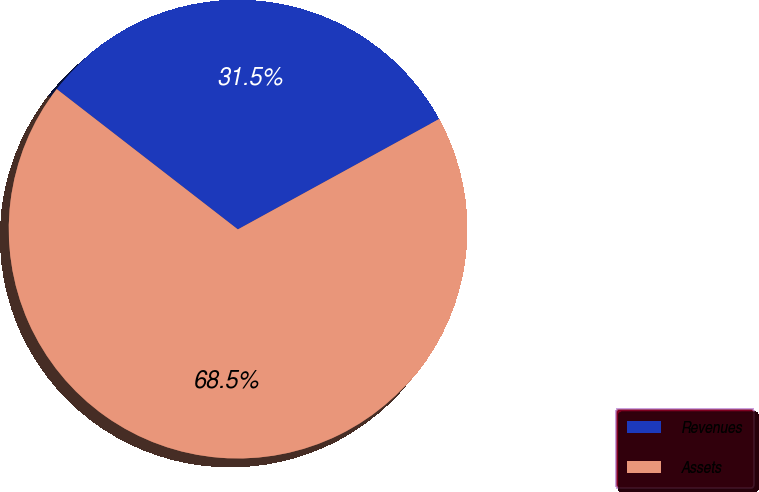Convert chart to OTSL. <chart><loc_0><loc_0><loc_500><loc_500><pie_chart><fcel>Revenues<fcel>Assets<nl><fcel>31.53%<fcel>68.47%<nl></chart> 